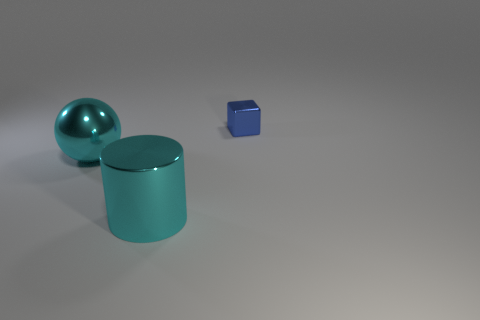What is the color of the big sphere that is made of the same material as the cylinder?
Your answer should be compact. Cyan. How many large cyan objects have the same material as the cube?
Keep it short and to the point. 2. There is a cyan thing that is behind the cyan shiny cylinder; is it the same size as the small object?
Provide a short and direct response. No. The shiny sphere that is the same size as the metallic cylinder is what color?
Offer a very short reply. Cyan. How many big cylinders are in front of the metal cube?
Give a very brief answer. 1. Is there a tiny purple shiny ball?
Give a very brief answer. No. There is a cyan thing behind the large thing right of the cyan metal object behind the shiny cylinder; what size is it?
Give a very brief answer. Large. What number of other objects are there of the same size as the blue metal block?
Give a very brief answer. 0. There is a cyan object on the left side of the shiny cylinder; how big is it?
Keep it short and to the point. Large. Is there anything else that has the same color as the sphere?
Your response must be concise. Yes. 